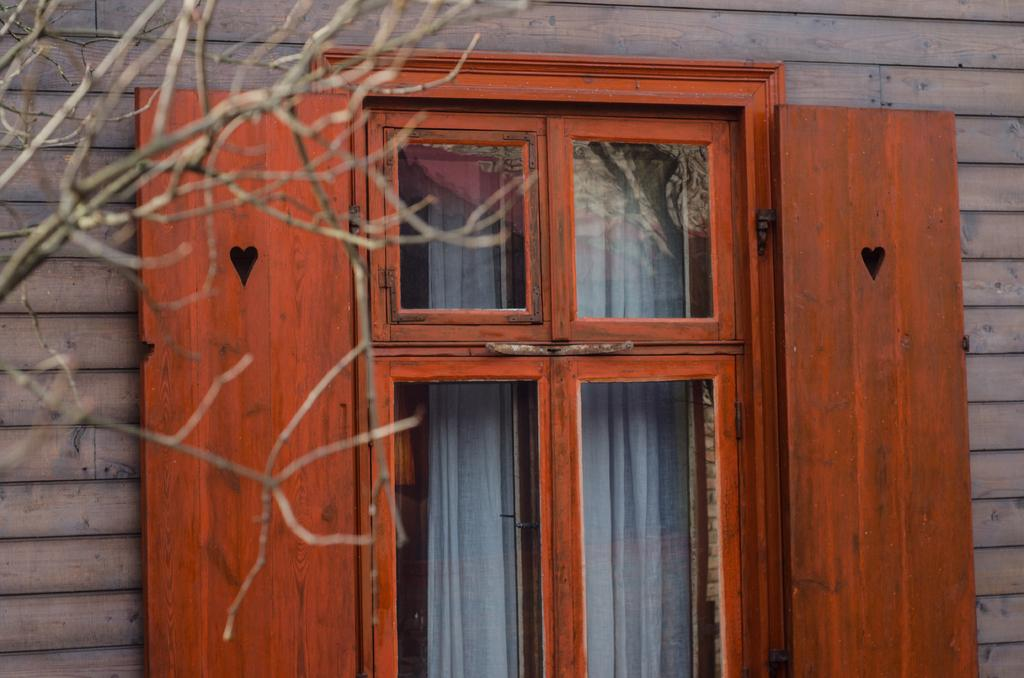What type of structure is visible in the image? There is a building in the image. What feature can be observed on the windows of the building? The building has glass windows, and one of them is orange-colored. Are there any doors in the building? Yes, there are doors in the building, and they are orange-colored. What can be found inside the building? Inside the building, there is a white-colored curtain. What is the condition of the trees in front of the building? In front of the building, there are dry trees. What type of corn is being polished in the image? There is no corn or polishing activity present in the image. The image features a building with orange-colored windows and doors, a white-colored curtain inside, and dry trees in front. 